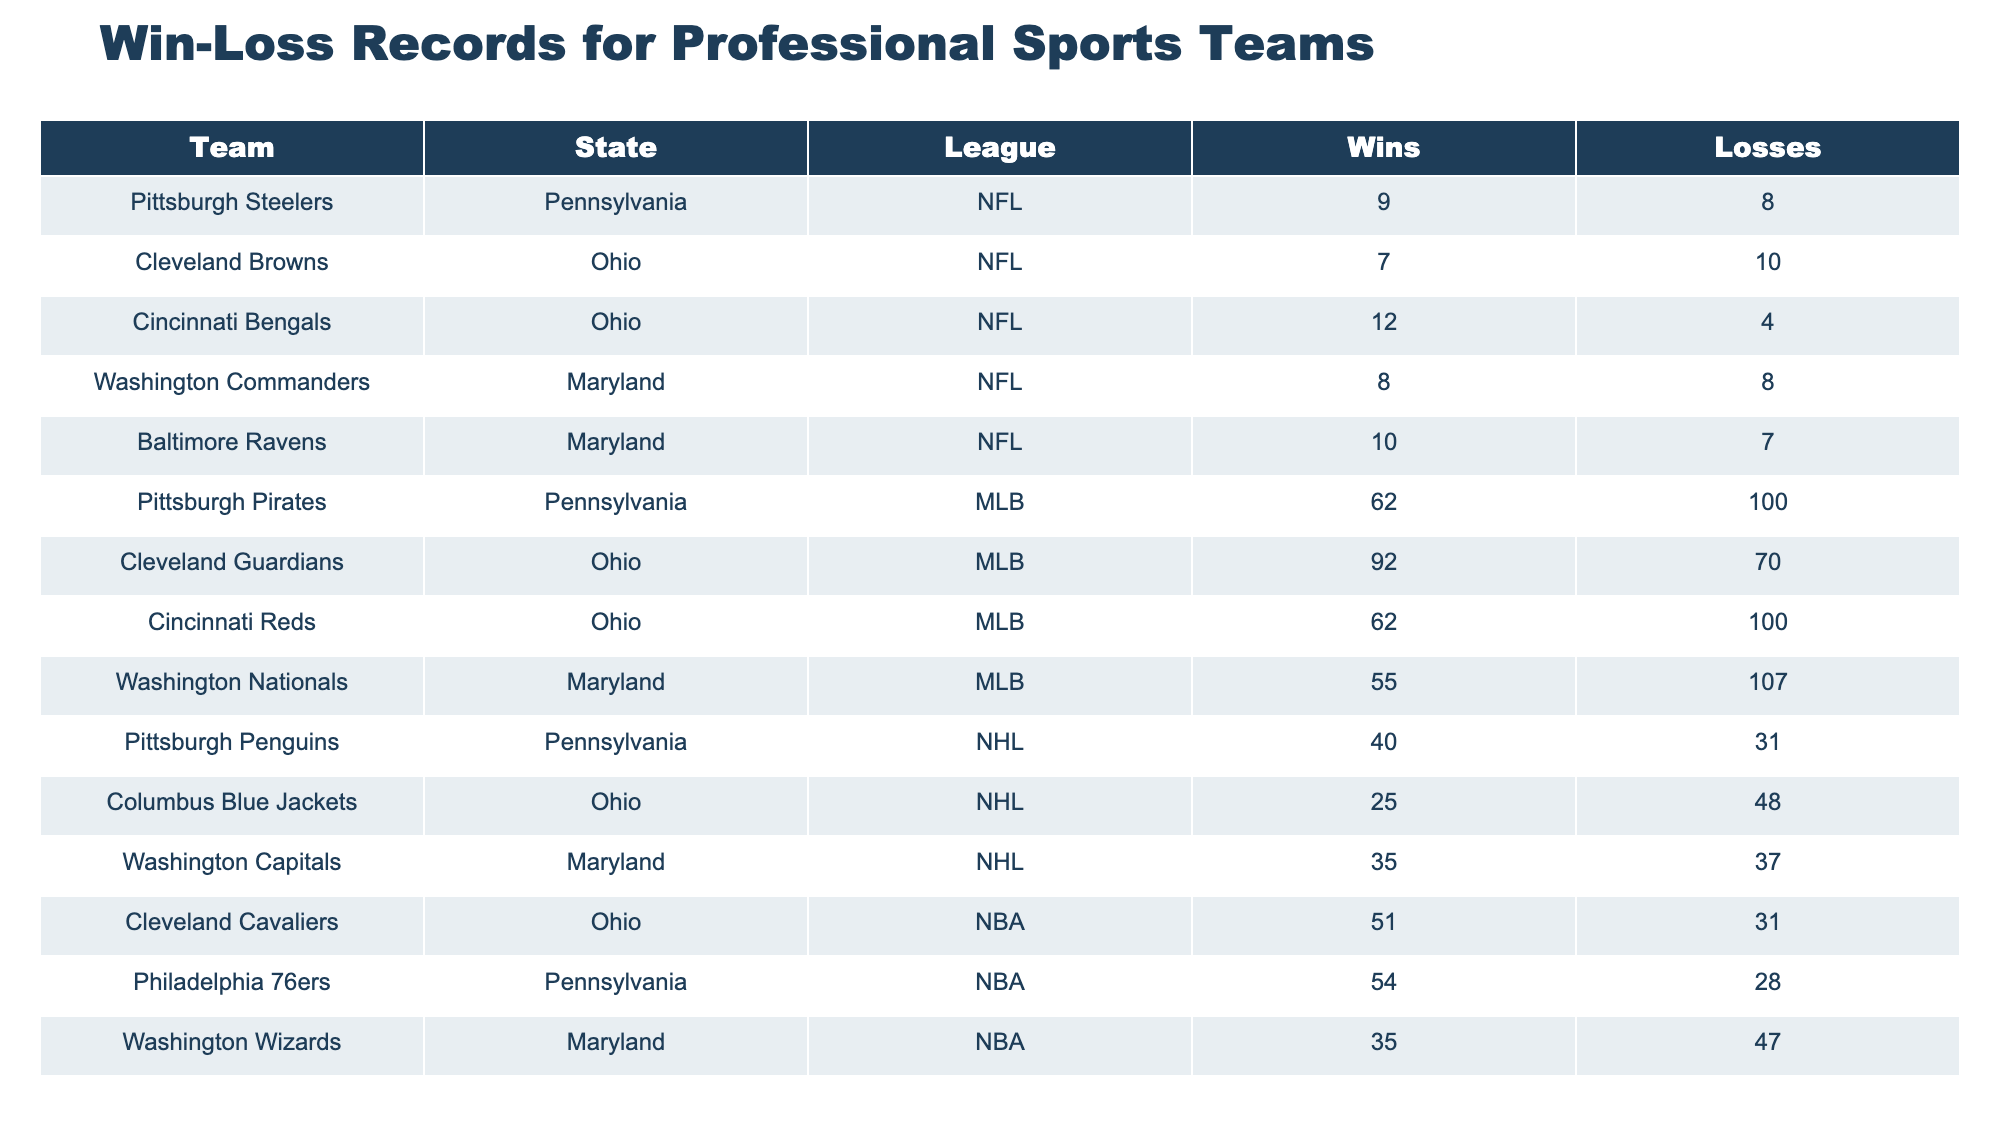What is the win-loss record of the Pittsburgh Steelers? The win-loss record of the Pittsburgh Steelers is found in the table, specifically in the row corresponding to their team. They have 9 wins and 8 losses.
Answer: 9 wins, 8 losses Which MLB team from Pennsylvania has the most losses? In the table, we compare the losses of the MLB teams from Pennsylvania, specifically the Pittsburgh Pirates (100 losses). The other team, the Pittsburgh Pirates, also has a record that confirms them as the team with the most losses in MLB from Pennsylvania.
Answer: Pittsburgh Pirates How many total wins do Ohio NFL teams have? The NFL teams from Ohio are the Cleveland Browns and the Cincinnati Bengals. Their wins are listed as 7 and 12, respectively. When we sum these: 7 + 12 = 19.
Answer: 19 Is it true that the Baltimore Ravens' win total is greater than that of the Washington Commanders? We look at the win totals in the table for both teams. The Baltimore Ravens have 10 wins, while the Washington Commanders have 8 wins. Since 10 is greater than 8, the statement is true.
Answer: Yes What is the average number of wins for the NBA teams based in Maryland? The NBA team from Maryland is the Washington Wizards, who have 35 wins. However, averaging requires knowing the total number of NBA teams based in Maryland. There is only one, which means the average is simply the number of wins that team has. Therefore, the average is calculated as 35/1 = 35.
Answer: 35 Which state has the highest total number of wins across all its teams in the table? We calculate the total wins for each state. Pennsylvania: Steelers (9) + Pirates (62) + Penguins (40) + 76ers (54) = 165. Ohio: Browns (7) + Guardians (92) + Bengals (12) + Reds (62) + Cavaliers (51) + Blue Jackets (25) = 249. Maryland: Commanders (8) + Ravens (10) + Nationals (55) + Capitals (35) + Wizards (35) = 143. Hence Ohio has the highest total with 249 wins.
Answer: Ohio What is the win-loss ratio for the Cincinnati Bengals? The ratio is calculated by dividing the number of wins by the number of losses. For the Cincinnati Bengals, they have 12 wins and 4 losses, leading to a calculation of 12/4 = 3. Therefore, the win-loss ratio is 3 to 1.
Answer: 3:1 How many more wins do the Cleveland Guardians have compared to the Cleveland Browns? The Cleveland Guardians have 92 wins, while the Cleveland Browns have 7 wins. The difference is calculated as 92 - 7 = 85.
Answer: 85 Do the Pittsburgh Penguins have more wins than the Washington Capitals? The table shows the Penguins have 40 wins while the Capitals have 35. Since 40 is greater than 35, the statement is true.
Answer: Yes 